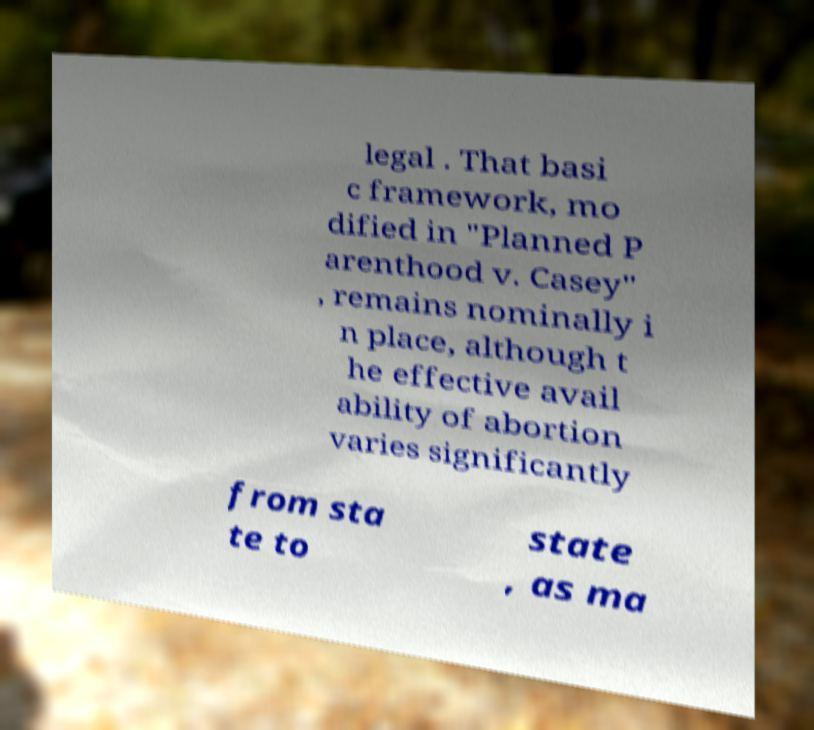Please identify and transcribe the text found in this image. legal . That basi c framework, mo dified in "Planned P arenthood v. Casey" , remains nominally i n place, although t he effective avail ability of abortion varies significantly from sta te to state , as ma 